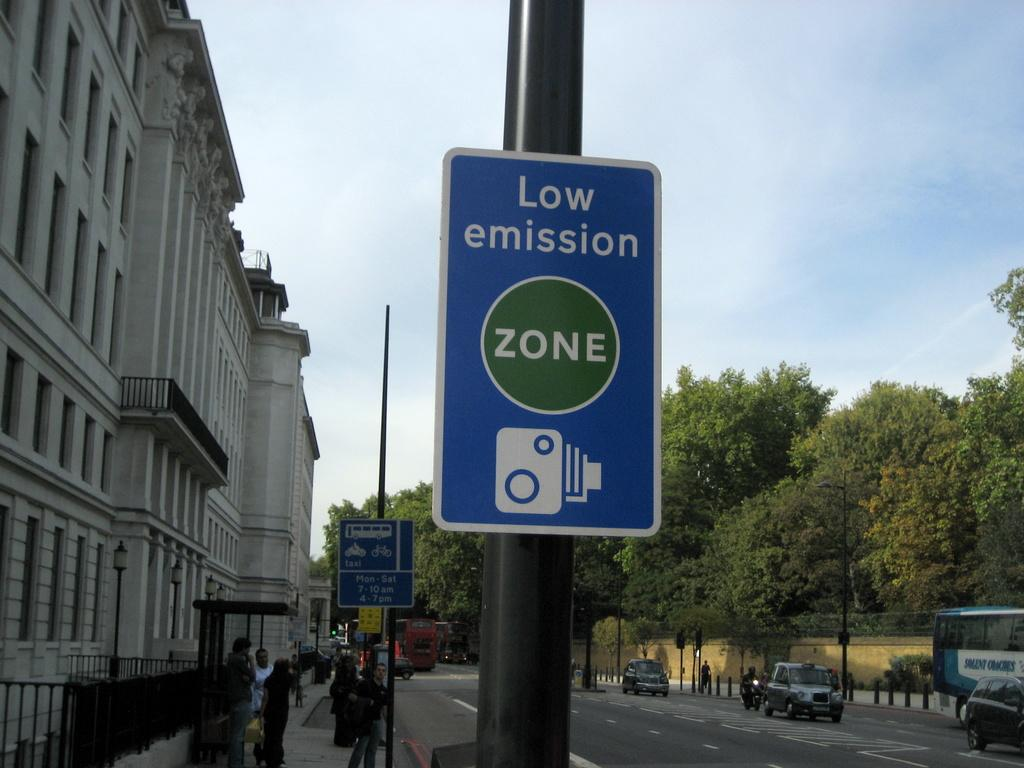<image>
Describe the image concisely. the word zone that is on a pole 